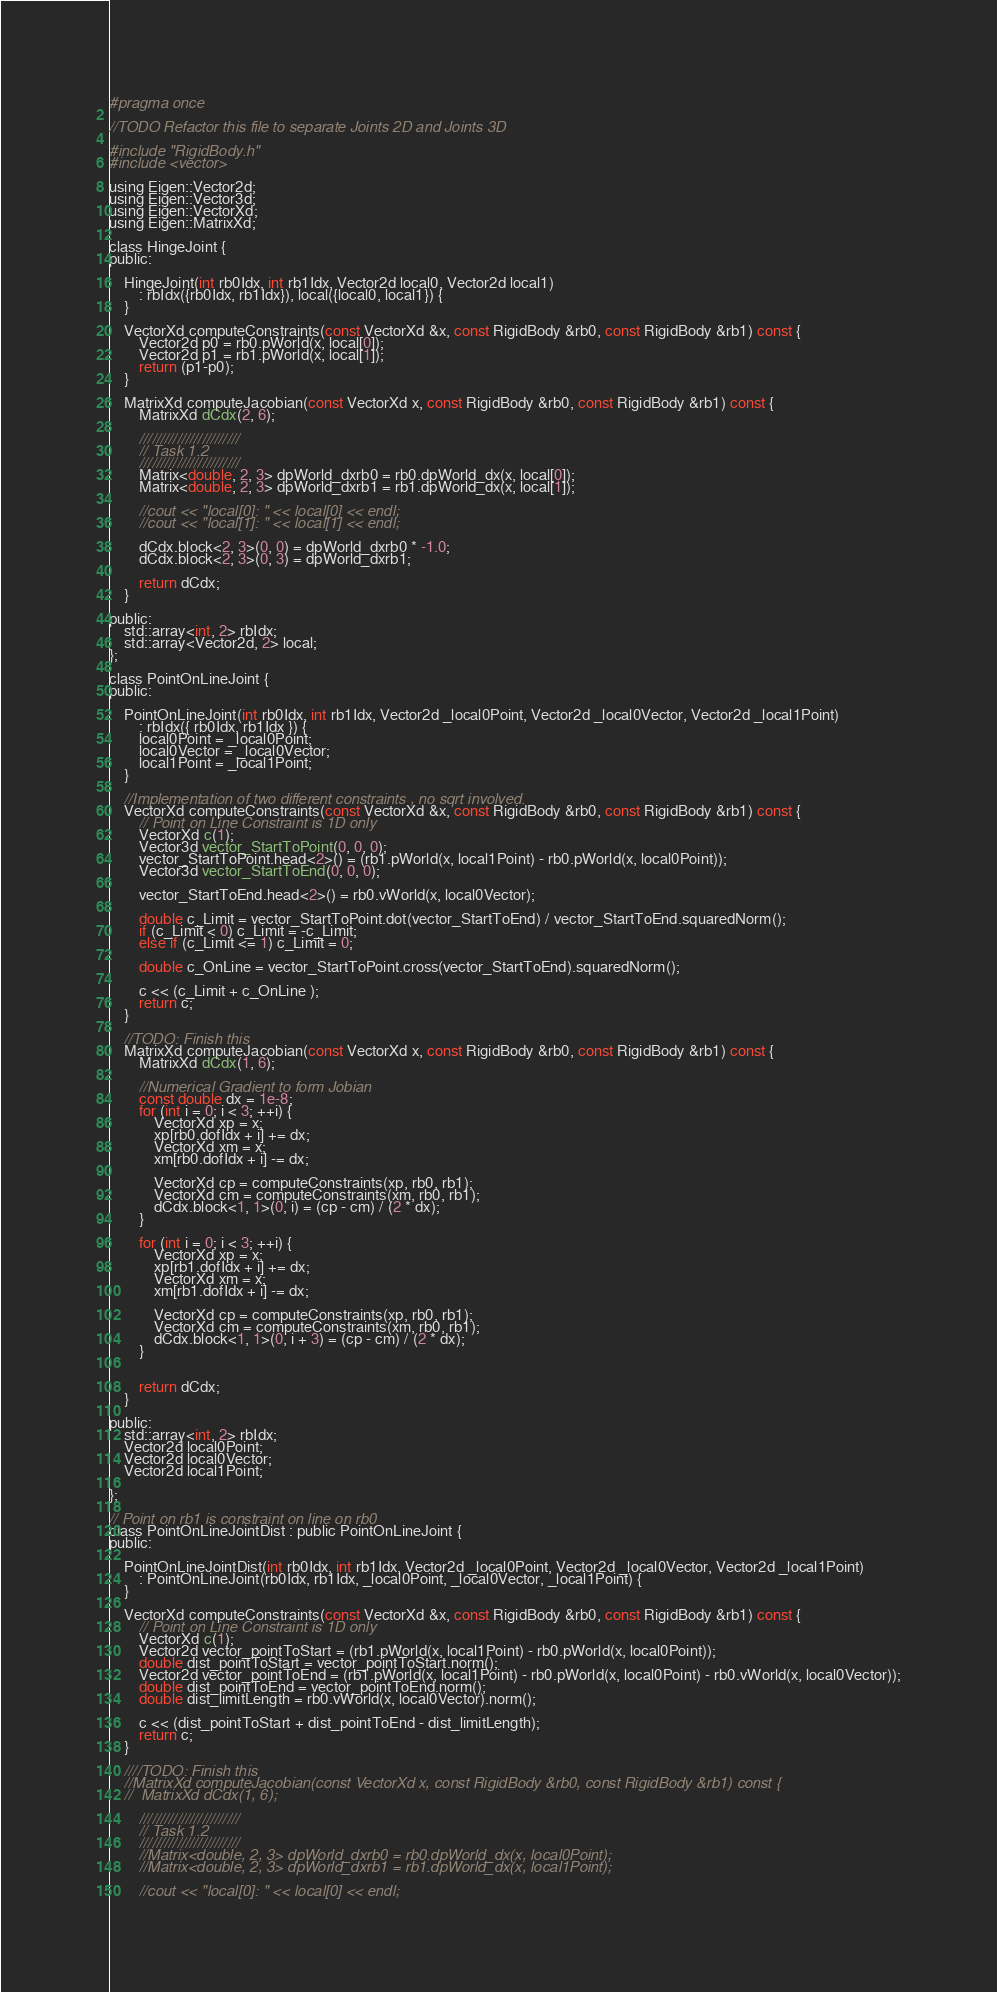Convert code to text. <code><loc_0><loc_0><loc_500><loc_500><_C_>#pragma once

//TODO Refactor this file to separate Joints 2D and Joints 3D

#include "RigidBody.h"
#include <vector>

using Eigen::Vector2d;
using Eigen::Vector3d;
using Eigen::VectorXd;
using Eigen::MatrixXd;

class HingeJoint {
public:

	HingeJoint(int rb0Idx, int rb1Idx, Vector2d local0, Vector2d local1)
		: rbIdx({rb0Idx, rb1Idx}), local({local0, local1}) {
	}

	VectorXd computeConstraints(const VectorXd &x, const RigidBody &rb0, const RigidBody &rb1) const {
		Vector2d p0 = rb0.pWorld(x, local[0]);
		Vector2d p1 = rb1.pWorld(x, local[1]);
        return (p1-p0);
	}

	MatrixXd computeJacobian(const VectorXd x, const RigidBody &rb0, const RigidBody &rb1) const {
		MatrixXd dCdx(2, 6);

        ////////////////////////
        // Task 1.2
        ////////////////////////
		Matrix<double, 2, 3> dpWorld_dxrb0 = rb0.dpWorld_dx(x, local[0]);
		Matrix<double, 2, 3> dpWorld_dxrb1 = rb1.dpWorld_dx(x, local[1]);

		//cout << "local[0]: " << local[0] << endl;
		//cout << "local[1]: " << local[1] << endl;

		dCdx.block<2, 3>(0, 0) = dpWorld_dxrb0 * -1.0;
		dCdx.block<2, 3>(0, 3) = dpWorld_dxrb1;

		return dCdx;
	}

public:
	std::array<int, 2> rbIdx;
	std::array<Vector2d, 2> local;
};

class PointOnLineJoint {
public:

	PointOnLineJoint(int rb0Idx, int rb1Idx, Vector2d _local0Point, Vector2d _local0Vector, Vector2d _local1Point)
		: rbIdx({ rb0Idx, rb1Idx }) {
		local0Point = _local0Point;
		local0Vector = _local0Vector;
		local1Point = _local1Point;
	}

	//Implementation of two different constraints , no sqrt involved.
	VectorXd computeConstraints(const VectorXd &x, const RigidBody &rb0, const RigidBody &rb1) const {
		// Point on Line Constraint is 1D only
		VectorXd c(1);
		Vector3d vector_StartToPoint(0, 0, 0);
		vector_StartToPoint.head<2>() = (rb1.pWorld(x, local1Point) - rb0.pWorld(x, local0Point));
		Vector3d vector_StartToEnd(0, 0, 0);

		vector_StartToEnd.head<2>() = rb0.vWorld(x, local0Vector);

		double c_Limit = vector_StartToPoint.dot(vector_StartToEnd) / vector_StartToEnd.squaredNorm();
		if (c_Limit < 0) c_Limit = -c_Limit;
		else if (c_Limit <= 1) c_Limit = 0;

		double c_OnLine = vector_StartToPoint.cross(vector_StartToEnd).squaredNorm();

		c << (c_Limit + c_OnLine );
		return c;
	}

	//TODO: Finish this
	MatrixXd computeJacobian(const VectorXd x, const RigidBody &rb0, const RigidBody &rb1) const {
		MatrixXd dCdx(1, 6);

		//Numerical Gradient to form Jobian
		const double dx = 1e-8;
		for (int i = 0; i < 3; ++i) {
			VectorXd xp = x;
			xp[rb0.dofIdx + i] += dx;
			VectorXd xm = x;
			xm[rb0.dofIdx + i] -= dx;

			VectorXd cp = computeConstraints(xp, rb0, rb1);
			VectorXd cm = computeConstraints(xm, rb0, rb1);
			dCdx.block<1, 1>(0, i) = (cp - cm) / (2 * dx);
		}

		for (int i = 0; i < 3; ++i) {
			VectorXd xp = x;
			xp[rb1.dofIdx + i] += dx;
			VectorXd xm = x;
			xm[rb1.dofIdx + i] -= dx;

			VectorXd cp = computeConstraints(xp, rb0, rb1);
			VectorXd cm = computeConstraints(xm, rb0, rb1);
			dCdx.block<1, 1>(0, i + 3) = (cp - cm) / (2 * dx);
		}


		return dCdx;
	}

public:
	std::array<int, 2> rbIdx;
	Vector2d local0Point;
	Vector2d local0Vector;
	Vector2d local1Point;

};

// Point on rb1 is constraint on line on rb0
class PointOnLineJointDist : public PointOnLineJoint {
public:

	PointOnLineJointDist(int rb0Idx, int rb1Idx, Vector2d _local0Point, Vector2d _local0Vector, Vector2d _local1Point)
		: PointOnLineJoint(rb0Idx, rb1Idx, _local0Point, _local0Vector, _local1Point) {
	}

	VectorXd computeConstraints(const VectorXd &x, const RigidBody &rb0, const RigidBody &rb1) const {
		// Point on Line Constraint is 1D only
		VectorXd c(1);
		Vector2d vector_pointToStart = (rb1.pWorld(x, local1Point) - rb0.pWorld(x, local0Point));
		double dist_pointToStart = vector_pointToStart.norm();
		Vector2d vector_pointToEnd = (rb1.pWorld(x, local1Point) - rb0.pWorld(x, local0Point) - rb0.vWorld(x, local0Vector));
		double dist_pointToEnd = vector_pointToEnd.norm();
		double dist_limitLength = rb0.vWorld(x, local0Vector).norm();

		c << (dist_pointToStart + dist_pointToEnd - dist_limitLength);
		return c;
	}

	////TODO: Finish this
	//MatrixXd computeJacobian(const VectorXd x, const RigidBody &rb0, const RigidBody &rb1) const {
	//	MatrixXd dCdx(1, 6);

		////////////////////////
		// Task 1.2
		////////////////////////
		//Matrix<double, 2, 3> dpWorld_dxrb0 = rb0.dpWorld_dx(x, local0Point);
		//Matrix<double, 2, 3> dpWorld_dxrb1 = rb1.dpWorld_dx(x, local1Point);

		//cout << "local[0]: " << local[0] << endl;</code> 